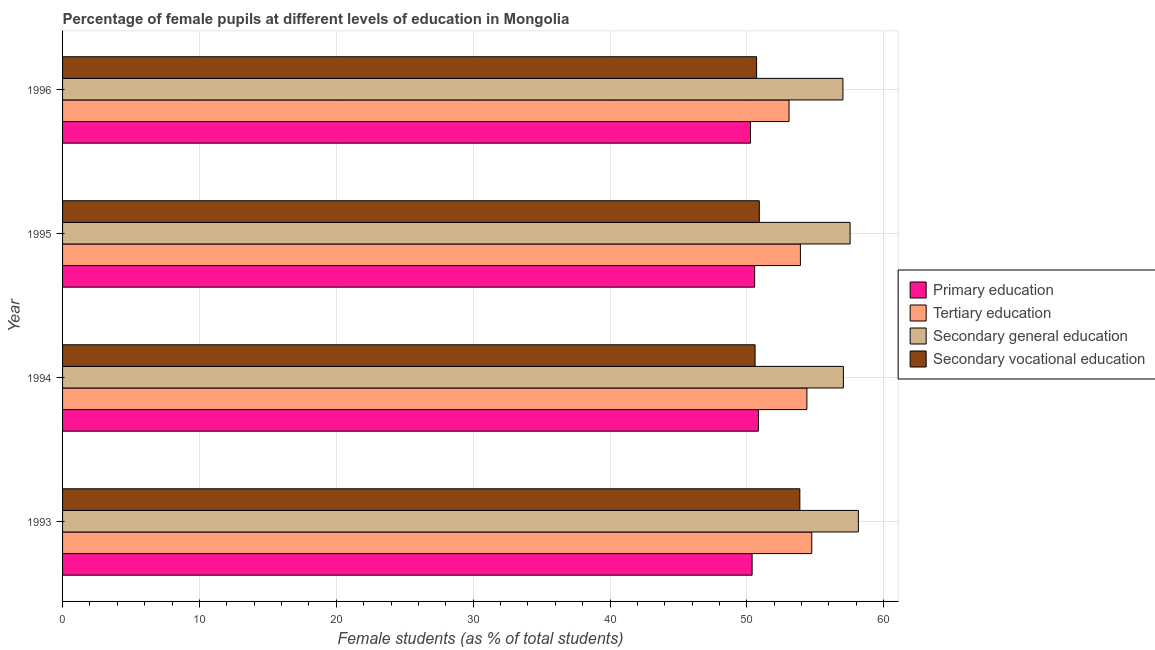Are the number of bars on each tick of the Y-axis equal?
Offer a terse response. Yes. How many bars are there on the 1st tick from the top?
Ensure brevity in your answer.  4. How many bars are there on the 1st tick from the bottom?
Ensure brevity in your answer.  4. What is the label of the 4th group of bars from the top?
Offer a very short reply. 1993. What is the percentage of female students in primary education in 1994?
Provide a short and direct response. 50.84. Across all years, what is the maximum percentage of female students in secondary vocational education?
Offer a terse response. 53.87. Across all years, what is the minimum percentage of female students in primary education?
Provide a short and direct response. 50.27. In which year was the percentage of female students in secondary education maximum?
Make the answer very short. 1993. In which year was the percentage of female students in secondary vocational education minimum?
Keep it short and to the point. 1994. What is the total percentage of female students in tertiary education in the graph?
Provide a succinct answer. 216.12. What is the difference between the percentage of female students in primary education in 1993 and that in 1995?
Give a very brief answer. -0.19. What is the difference between the percentage of female students in primary education in 1995 and the percentage of female students in secondary vocational education in 1996?
Give a very brief answer. -0.14. What is the average percentage of female students in secondary education per year?
Ensure brevity in your answer.  57.44. In the year 1994, what is the difference between the percentage of female students in primary education and percentage of female students in secondary vocational education?
Give a very brief answer. 0.24. What is the ratio of the percentage of female students in secondary vocational education in 1993 to that in 1995?
Make the answer very short. 1.06. Is the percentage of female students in tertiary education in 1993 less than that in 1994?
Provide a succinct answer. No. Is the difference between the percentage of female students in tertiary education in 1994 and 1995 greater than the difference between the percentage of female students in primary education in 1994 and 1995?
Your answer should be compact. Yes. What is the difference between the highest and the second highest percentage of female students in primary education?
Ensure brevity in your answer.  0.27. What is the difference between the highest and the lowest percentage of female students in secondary vocational education?
Your response must be concise. 3.27. In how many years, is the percentage of female students in tertiary education greater than the average percentage of female students in tertiary education taken over all years?
Make the answer very short. 2. Is the sum of the percentage of female students in secondary vocational education in 1994 and 1996 greater than the maximum percentage of female students in primary education across all years?
Offer a terse response. Yes. Is it the case that in every year, the sum of the percentage of female students in secondary vocational education and percentage of female students in primary education is greater than the sum of percentage of female students in tertiary education and percentage of female students in secondary education?
Your answer should be very brief. No. What does the 3rd bar from the top in 1996 represents?
Offer a terse response. Tertiary education. Is it the case that in every year, the sum of the percentage of female students in primary education and percentage of female students in tertiary education is greater than the percentage of female students in secondary education?
Provide a succinct answer. Yes. How many years are there in the graph?
Ensure brevity in your answer.  4. What is the difference between two consecutive major ticks on the X-axis?
Your response must be concise. 10. Does the graph contain any zero values?
Ensure brevity in your answer.  No. How are the legend labels stacked?
Ensure brevity in your answer.  Vertical. What is the title of the graph?
Ensure brevity in your answer.  Percentage of female pupils at different levels of education in Mongolia. What is the label or title of the X-axis?
Your answer should be very brief. Female students (as % of total students). What is the Female students (as % of total students) in Primary education in 1993?
Provide a succinct answer. 50.38. What is the Female students (as % of total students) in Tertiary education in 1993?
Provide a succinct answer. 54.74. What is the Female students (as % of total students) in Secondary general education in 1993?
Offer a very short reply. 58.15. What is the Female students (as % of total students) in Secondary vocational education in 1993?
Provide a succinct answer. 53.87. What is the Female students (as % of total students) of Primary education in 1994?
Your response must be concise. 50.84. What is the Female students (as % of total students) in Tertiary education in 1994?
Your answer should be compact. 54.39. What is the Female students (as % of total students) in Secondary general education in 1994?
Ensure brevity in your answer.  57.05. What is the Female students (as % of total students) in Secondary vocational education in 1994?
Give a very brief answer. 50.6. What is the Female students (as % of total students) in Primary education in 1995?
Provide a short and direct response. 50.57. What is the Female students (as % of total students) of Tertiary education in 1995?
Give a very brief answer. 53.91. What is the Female students (as % of total students) of Secondary general education in 1995?
Offer a terse response. 57.54. What is the Female students (as % of total students) of Secondary vocational education in 1995?
Keep it short and to the point. 50.91. What is the Female students (as % of total students) of Primary education in 1996?
Your answer should be very brief. 50.27. What is the Female students (as % of total students) in Tertiary education in 1996?
Keep it short and to the point. 53.08. What is the Female students (as % of total students) of Secondary general education in 1996?
Your response must be concise. 57.02. What is the Female students (as % of total students) of Secondary vocational education in 1996?
Provide a succinct answer. 50.71. Across all years, what is the maximum Female students (as % of total students) in Primary education?
Ensure brevity in your answer.  50.84. Across all years, what is the maximum Female students (as % of total students) in Tertiary education?
Your answer should be compact. 54.74. Across all years, what is the maximum Female students (as % of total students) of Secondary general education?
Provide a short and direct response. 58.15. Across all years, what is the maximum Female students (as % of total students) in Secondary vocational education?
Give a very brief answer. 53.87. Across all years, what is the minimum Female students (as % of total students) of Primary education?
Keep it short and to the point. 50.27. Across all years, what is the minimum Female students (as % of total students) in Tertiary education?
Your answer should be very brief. 53.08. Across all years, what is the minimum Female students (as % of total students) in Secondary general education?
Provide a succinct answer. 57.02. Across all years, what is the minimum Female students (as % of total students) of Secondary vocational education?
Make the answer very short. 50.6. What is the total Female students (as % of total students) of Primary education in the graph?
Make the answer very short. 202.06. What is the total Female students (as % of total students) in Tertiary education in the graph?
Offer a terse response. 216.12. What is the total Female students (as % of total students) of Secondary general education in the graph?
Your answer should be compact. 229.76. What is the total Female students (as % of total students) in Secondary vocational education in the graph?
Your answer should be very brief. 206.09. What is the difference between the Female students (as % of total students) in Primary education in 1993 and that in 1994?
Provide a short and direct response. -0.46. What is the difference between the Female students (as % of total students) in Tertiary education in 1993 and that in 1994?
Your answer should be compact. 0.36. What is the difference between the Female students (as % of total students) in Secondary general education in 1993 and that in 1994?
Provide a succinct answer. 1.09. What is the difference between the Female students (as % of total students) in Secondary vocational education in 1993 and that in 1994?
Offer a very short reply. 3.27. What is the difference between the Female students (as % of total students) of Primary education in 1993 and that in 1995?
Your answer should be compact. -0.19. What is the difference between the Female students (as % of total students) of Tertiary education in 1993 and that in 1995?
Give a very brief answer. 0.83. What is the difference between the Female students (as % of total students) of Secondary general education in 1993 and that in 1995?
Ensure brevity in your answer.  0.6. What is the difference between the Female students (as % of total students) in Secondary vocational education in 1993 and that in 1995?
Provide a succinct answer. 2.96. What is the difference between the Female students (as % of total students) of Primary education in 1993 and that in 1996?
Ensure brevity in your answer.  0.12. What is the difference between the Female students (as % of total students) in Tertiary education in 1993 and that in 1996?
Your answer should be very brief. 1.66. What is the difference between the Female students (as % of total students) in Secondary general education in 1993 and that in 1996?
Offer a very short reply. 1.13. What is the difference between the Female students (as % of total students) in Secondary vocational education in 1993 and that in 1996?
Your answer should be compact. 3.16. What is the difference between the Female students (as % of total students) of Primary education in 1994 and that in 1995?
Your response must be concise. 0.27. What is the difference between the Female students (as % of total students) of Tertiary education in 1994 and that in 1995?
Your response must be concise. 0.48. What is the difference between the Female students (as % of total students) of Secondary general education in 1994 and that in 1995?
Offer a terse response. -0.49. What is the difference between the Female students (as % of total students) in Secondary vocational education in 1994 and that in 1995?
Your answer should be very brief. -0.31. What is the difference between the Female students (as % of total students) in Primary education in 1994 and that in 1996?
Provide a short and direct response. 0.58. What is the difference between the Female students (as % of total students) of Tertiary education in 1994 and that in 1996?
Offer a terse response. 1.3. What is the difference between the Female students (as % of total students) of Secondary general education in 1994 and that in 1996?
Offer a very short reply. 0.03. What is the difference between the Female students (as % of total students) in Secondary vocational education in 1994 and that in 1996?
Your answer should be very brief. -0.11. What is the difference between the Female students (as % of total students) of Primary education in 1995 and that in 1996?
Provide a short and direct response. 0.3. What is the difference between the Female students (as % of total students) of Tertiary education in 1995 and that in 1996?
Your answer should be compact. 0.83. What is the difference between the Female students (as % of total students) in Secondary general education in 1995 and that in 1996?
Ensure brevity in your answer.  0.52. What is the difference between the Female students (as % of total students) in Secondary vocational education in 1995 and that in 1996?
Your response must be concise. 0.2. What is the difference between the Female students (as % of total students) in Primary education in 1993 and the Female students (as % of total students) in Tertiary education in 1994?
Your answer should be very brief. -4. What is the difference between the Female students (as % of total students) of Primary education in 1993 and the Female students (as % of total students) of Secondary general education in 1994?
Your answer should be very brief. -6.67. What is the difference between the Female students (as % of total students) of Primary education in 1993 and the Female students (as % of total students) of Secondary vocational education in 1994?
Ensure brevity in your answer.  -0.22. What is the difference between the Female students (as % of total students) of Tertiary education in 1993 and the Female students (as % of total students) of Secondary general education in 1994?
Make the answer very short. -2.31. What is the difference between the Female students (as % of total students) of Tertiary education in 1993 and the Female students (as % of total students) of Secondary vocational education in 1994?
Your response must be concise. 4.14. What is the difference between the Female students (as % of total students) in Secondary general education in 1993 and the Female students (as % of total students) in Secondary vocational education in 1994?
Keep it short and to the point. 7.55. What is the difference between the Female students (as % of total students) of Primary education in 1993 and the Female students (as % of total students) of Tertiary education in 1995?
Ensure brevity in your answer.  -3.53. What is the difference between the Female students (as % of total students) in Primary education in 1993 and the Female students (as % of total students) in Secondary general education in 1995?
Keep it short and to the point. -7.16. What is the difference between the Female students (as % of total students) of Primary education in 1993 and the Female students (as % of total students) of Secondary vocational education in 1995?
Offer a terse response. -0.53. What is the difference between the Female students (as % of total students) of Tertiary education in 1993 and the Female students (as % of total students) of Secondary general education in 1995?
Give a very brief answer. -2.8. What is the difference between the Female students (as % of total students) of Tertiary education in 1993 and the Female students (as % of total students) of Secondary vocational education in 1995?
Keep it short and to the point. 3.83. What is the difference between the Female students (as % of total students) of Secondary general education in 1993 and the Female students (as % of total students) of Secondary vocational education in 1995?
Ensure brevity in your answer.  7.24. What is the difference between the Female students (as % of total students) of Primary education in 1993 and the Female students (as % of total students) of Tertiary education in 1996?
Your answer should be very brief. -2.7. What is the difference between the Female students (as % of total students) in Primary education in 1993 and the Female students (as % of total students) in Secondary general education in 1996?
Give a very brief answer. -6.64. What is the difference between the Female students (as % of total students) in Primary education in 1993 and the Female students (as % of total students) in Secondary vocational education in 1996?
Make the answer very short. -0.33. What is the difference between the Female students (as % of total students) in Tertiary education in 1993 and the Female students (as % of total students) in Secondary general education in 1996?
Your answer should be compact. -2.28. What is the difference between the Female students (as % of total students) of Tertiary education in 1993 and the Female students (as % of total students) of Secondary vocational education in 1996?
Give a very brief answer. 4.03. What is the difference between the Female students (as % of total students) of Secondary general education in 1993 and the Female students (as % of total students) of Secondary vocational education in 1996?
Keep it short and to the point. 7.43. What is the difference between the Female students (as % of total students) in Primary education in 1994 and the Female students (as % of total students) in Tertiary education in 1995?
Your answer should be very brief. -3.07. What is the difference between the Female students (as % of total students) of Primary education in 1994 and the Female students (as % of total students) of Secondary general education in 1995?
Offer a very short reply. -6.7. What is the difference between the Female students (as % of total students) in Primary education in 1994 and the Female students (as % of total students) in Secondary vocational education in 1995?
Keep it short and to the point. -0.07. What is the difference between the Female students (as % of total students) in Tertiary education in 1994 and the Female students (as % of total students) in Secondary general education in 1995?
Provide a short and direct response. -3.16. What is the difference between the Female students (as % of total students) in Tertiary education in 1994 and the Female students (as % of total students) in Secondary vocational education in 1995?
Ensure brevity in your answer.  3.48. What is the difference between the Female students (as % of total students) in Secondary general education in 1994 and the Female students (as % of total students) in Secondary vocational education in 1995?
Provide a succinct answer. 6.14. What is the difference between the Female students (as % of total students) in Primary education in 1994 and the Female students (as % of total students) in Tertiary education in 1996?
Give a very brief answer. -2.24. What is the difference between the Female students (as % of total students) in Primary education in 1994 and the Female students (as % of total students) in Secondary general education in 1996?
Give a very brief answer. -6.18. What is the difference between the Female students (as % of total students) in Primary education in 1994 and the Female students (as % of total students) in Secondary vocational education in 1996?
Provide a succinct answer. 0.13. What is the difference between the Female students (as % of total students) of Tertiary education in 1994 and the Female students (as % of total students) of Secondary general education in 1996?
Your answer should be very brief. -2.63. What is the difference between the Female students (as % of total students) in Tertiary education in 1994 and the Female students (as % of total students) in Secondary vocational education in 1996?
Provide a short and direct response. 3.67. What is the difference between the Female students (as % of total students) of Secondary general education in 1994 and the Female students (as % of total students) of Secondary vocational education in 1996?
Offer a very short reply. 6.34. What is the difference between the Female students (as % of total students) in Primary education in 1995 and the Female students (as % of total students) in Tertiary education in 1996?
Provide a succinct answer. -2.51. What is the difference between the Female students (as % of total students) in Primary education in 1995 and the Female students (as % of total students) in Secondary general education in 1996?
Ensure brevity in your answer.  -6.45. What is the difference between the Female students (as % of total students) in Primary education in 1995 and the Female students (as % of total students) in Secondary vocational education in 1996?
Your answer should be compact. -0.14. What is the difference between the Female students (as % of total students) of Tertiary education in 1995 and the Female students (as % of total students) of Secondary general education in 1996?
Ensure brevity in your answer.  -3.11. What is the difference between the Female students (as % of total students) of Tertiary education in 1995 and the Female students (as % of total students) of Secondary vocational education in 1996?
Make the answer very short. 3.2. What is the difference between the Female students (as % of total students) of Secondary general education in 1995 and the Female students (as % of total students) of Secondary vocational education in 1996?
Make the answer very short. 6.83. What is the average Female students (as % of total students) in Primary education per year?
Your response must be concise. 50.52. What is the average Female students (as % of total students) in Tertiary education per year?
Keep it short and to the point. 54.03. What is the average Female students (as % of total students) in Secondary general education per year?
Ensure brevity in your answer.  57.44. What is the average Female students (as % of total students) of Secondary vocational education per year?
Keep it short and to the point. 51.52. In the year 1993, what is the difference between the Female students (as % of total students) in Primary education and Female students (as % of total students) in Tertiary education?
Your answer should be very brief. -4.36. In the year 1993, what is the difference between the Female students (as % of total students) of Primary education and Female students (as % of total students) of Secondary general education?
Offer a very short reply. -7.76. In the year 1993, what is the difference between the Female students (as % of total students) in Primary education and Female students (as % of total students) in Secondary vocational education?
Provide a short and direct response. -3.49. In the year 1993, what is the difference between the Female students (as % of total students) in Tertiary education and Female students (as % of total students) in Secondary general education?
Keep it short and to the point. -3.4. In the year 1993, what is the difference between the Female students (as % of total students) in Tertiary education and Female students (as % of total students) in Secondary vocational education?
Ensure brevity in your answer.  0.87. In the year 1993, what is the difference between the Female students (as % of total students) of Secondary general education and Female students (as % of total students) of Secondary vocational education?
Offer a terse response. 4.28. In the year 1994, what is the difference between the Female students (as % of total students) of Primary education and Female students (as % of total students) of Tertiary education?
Give a very brief answer. -3.54. In the year 1994, what is the difference between the Female students (as % of total students) in Primary education and Female students (as % of total students) in Secondary general education?
Provide a short and direct response. -6.21. In the year 1994, what is the difference between the Female students (as % of total students) of Primary education and Female students (as % of total students) of Secondary vocational education?
Give a very brief answer. 0.24. In the year 1994, what is the difference between the Female students (as % of total students) of Tertiary education and Female students (as % of total students) of Secondary general education?
Ensure brevity in your answer.  -2.67. In the year 1994, what is the difference between the Female students (as % of total students) of Tertiary education and Female students (as % of total students) of Secondary vocational education?
Your answer should be very brief. 3.79. In the year 1994, what is the difference between the Female students (as % of total students) of Secondary general education and Female students (as % of total students) of Secondary vocational education?
Your answer should be very brief. 6.45. In the year 1995, what is the difference between the Female students (as % of total students) in Primary education and Female students (as % of total students) in Tertiary education?
Your answer should be compact. -3.34. In the year 1995, what is the difference between the Female students (as % of total students) of Primary education and Female students (as % of total students) of Secondary general education?
Your answer should be compact. -6.97. In the year 1995, what is the difference between the Female students (as % of total students) of Primary education and Female students (as % of total students) of Secondary vocational education?
Make the answer very short. -0.34. In the year 1995, what is the difference between the Female students (as % of total students) in Tertiary education and Female students (as % of total students) in Secondary general education?
Your answer should be compact. -3.63. In the year 1995, what is the difference between the Female students (as % of total students) of Tertiary education and Female students (as % of total students) of Secondary vocational education?
Offer a terse response. 3. In the year 1995, what is the difference between the Female students (as % of total students) in Secondary general education and Female students (as % of total students) in Secondary vocational education?
Your answer should be compact. 6.63. In the year 1996, what is the difference between the Female students (as % of total students) of Primary education and Female students (as % of total students) of Tertiary education?
Your answer should be compact. -2.82. In the year 1996, what is the difference between the Female students (as % of total students) of Primary education and Female students (as % of total students) of Secondary general education?
Your answer should be very brief. -6.75. In the year 1996, what is the difference between the Female students (as % of total students) of Primary education and Female students (as % of total students) of Secondary vocational education?
Your response must be concise. -0.45. In the year 1996, what is the difference between the Female students (as % of total students) in Tertiary education and Female students (as % of total students) in Secondary general education?
Make the answer very short. -3.94. In the year 1996, what is the difference between the Female students (as % of total students) of Tertiary education and Female students (as % of total students) of Secondary vocational education?
Give a very brief answer. 2.37. In the year 1996, what is the difference between the Female students (as % of total students) of Secondary general education and Female students (as % of total students) of Secondary vocational education?
Provide a short and direct response. 6.31. What is the ratio of the Female students (as % of total students) in Primary education in 1993 to that in 1994?
Your answer should be very brief. 0.99. What is the ratio of the Female students (as % of total students) of Secondary general education in 1993 to that in 1994?
Provide a succinct answer. 1.02. What is the ratio of the Female students (as % of total students) of Secondary vocational education in 1993 to that in 1994?
Provide a succinct answer. 1.06. What is the ratio of the Female students (as % of total students) of Primary education in 1993 to that in 1995?
Keep it short and to the point. 1. What is the ratio of the Female students (as % of total students) of Tertiary education in 1993 to that in 1995?
Your response must be concise. 1.02. What is the ratio of the Female students (as % of total students) of Secondary general education in 1993 to that in 1995?
Your response must be concise. 1.01. What is the ratio of the Female students (as % of total students) in Secondary vocational education in 1993 to that in 1995?
Your answer should be compact. 1.06. What is the ratio of the Female students (as % of total students) in Primary education in 1993 to that in 1996?
Offer a very short reply. 1. What is the ratio of the Female students (as % of total students) of Tertiary education in 1993 to that in 1996?
Keep it short and to the point. 1.03. What is the ratio of the Female students (as % of total students) of Secondary general education in 1993 to that in 1996?
Make the answer very short. 1.02. What is the ratio of the Female students (as % of total students) in Secondary vocational education in 1993 to that in 1996?
Offer a very short reply. 1.06. What is the ratio of the Female students (as % of total students) in Primary education in 1994 to that in 1995?
Ensure brevity in your answer.  1.01. What is the ratio of the Female students (as % of total students) in Tertiary education in 1994 to that in 1995?
Your response must be concise. 1.01. What is the ratio of the Female students (as % of total students) of Secondary vocational education in 1994 to that in 1995?
Your response must be concise. 0.99. What is the ratio of the Female students (as % of total students) in Primary education in 1994 to that in 1996?
Provide a short and direct response. 1.01. What is the ratio of the Female students (as % of total students) in Tertiary education in 1994 to that in 1996?
Provide a succinct answer. 1.02. What is the ratio of the Female students (as % of total students) of Secondary vocational education in 1994 to that in 1996?
Offer a terse response. 1. What is the ratio of the Female students (as % of total students) in Tertiary education in 1995 to that in 1996?
Keep it short and to the point. 1.02. What is the ratio of the Female students (as % of total students) in Secondary general education in 1995 to that in 1996?
Provide a succinct answer. 1.01. What is the difference between the highest and the second highest Female students (as % of total students) in Primary education?
Your answer should be very brief. 0.27. What is the difference between the highest and the second highest Female students (as % of total students) in Tertiary education?
Ensure brevity in your answer.  0.36. What is the difference between the highest and the second highest Female students (as % of total students) in Secondary general education?
Give a very brief answer. 0.6. What is the difference between the highest and the second highest Female students (as % of total students) of Secondary vocational education?
Offer a very short reply. 2.96. What is the difference between the highest and the lowest Female students (as % of total students) in Primary education?
Provide a succinct answer. 0.58. What is the difference between the highest and the lowest Female students (as % of total students) of Tertiary education?
Make the answer very short. 1.66. What is the difference between the highest and the lowest Female students (as % of total students) in Secondary general education?
Ensure brevity in your answer.  1.13. What is the difference between the highest and the lowest Female students (as % of total students) in Secondary vocational education?
Keep it short and to the point. 3.27. 